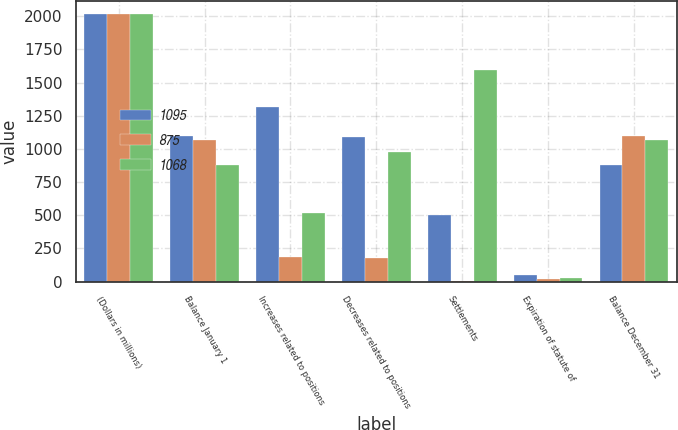<chart> <loc_0><loc_0><loc_500><loc_500><stacked_bar_chart><ecel><fcel>(Dollars in millions)<fcel>Balance January 1<fcel>Increases related to positions<fcel>Decreases related to positions<fcel>Settlements<fcel>Expiration of statute of<fcel>Balance December 31<nl><fcel>1095<fcel>2016<fcel>1095<fcel>1318<fcel>1091<fcel>503<fcel>48<fcel>875<nl><fcel>875<fcel>2015<fcel>1068<fcel>187<fcel>177<fcel>1<fcel>18<fcel>1095<nl><fcel>1068<fcel>2014<fcel>875<fcel>519<fcel>973<fcel>1594<fcel>27<fcel>1068<nl></chart> 